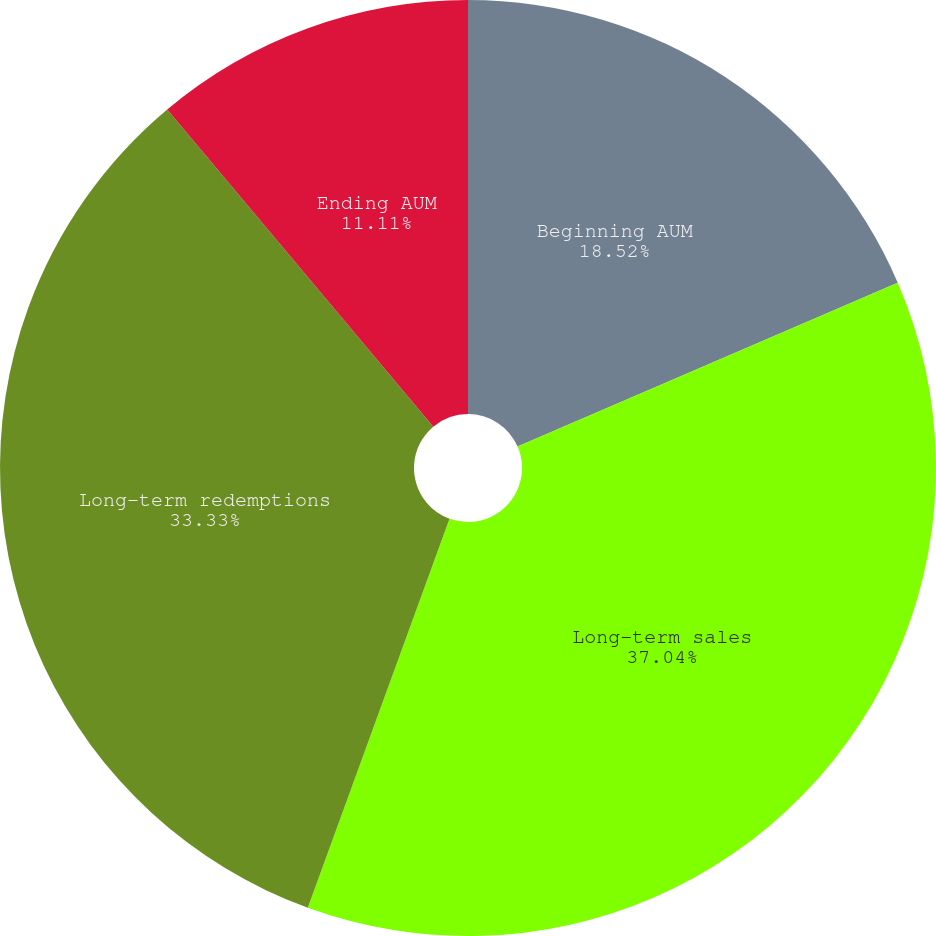Convert chart to OTSL. <chart><loc_0><loc_0><loc_500><loc_500><pie_chart><fcel>Beginning AUM<fcel>Long-term sales<fcel>Long-term redemptions<fcel>Ending AUM<nl><fcel>18.52%<fcel>37.04%<fcel>33.33%<fcel>11.11%<nl></chart> 